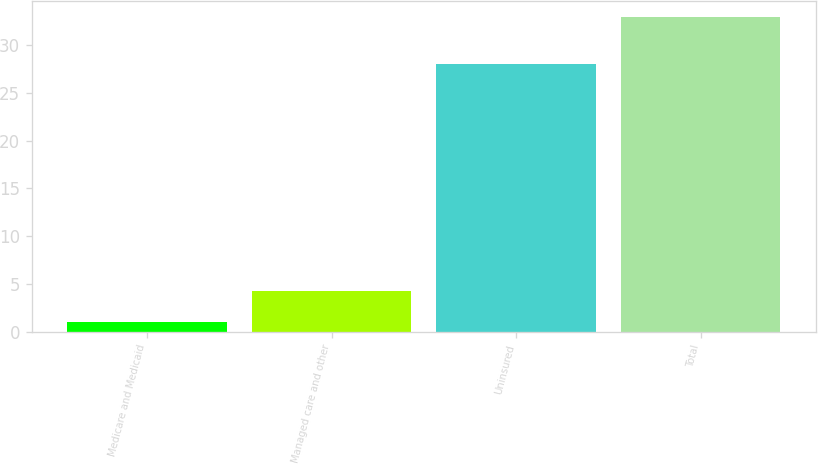Convert chart to OTSL. <chart><loc_0><loc_0><loc_500><loc_500><bar_chart><fcel>Medicare and Medicaid<fcel>Managed care and other<fcel>Uninsured<fcel>Total<nl><fcel>1<fcel>4.2<fcel>28<fcel>33<nl></chart> 